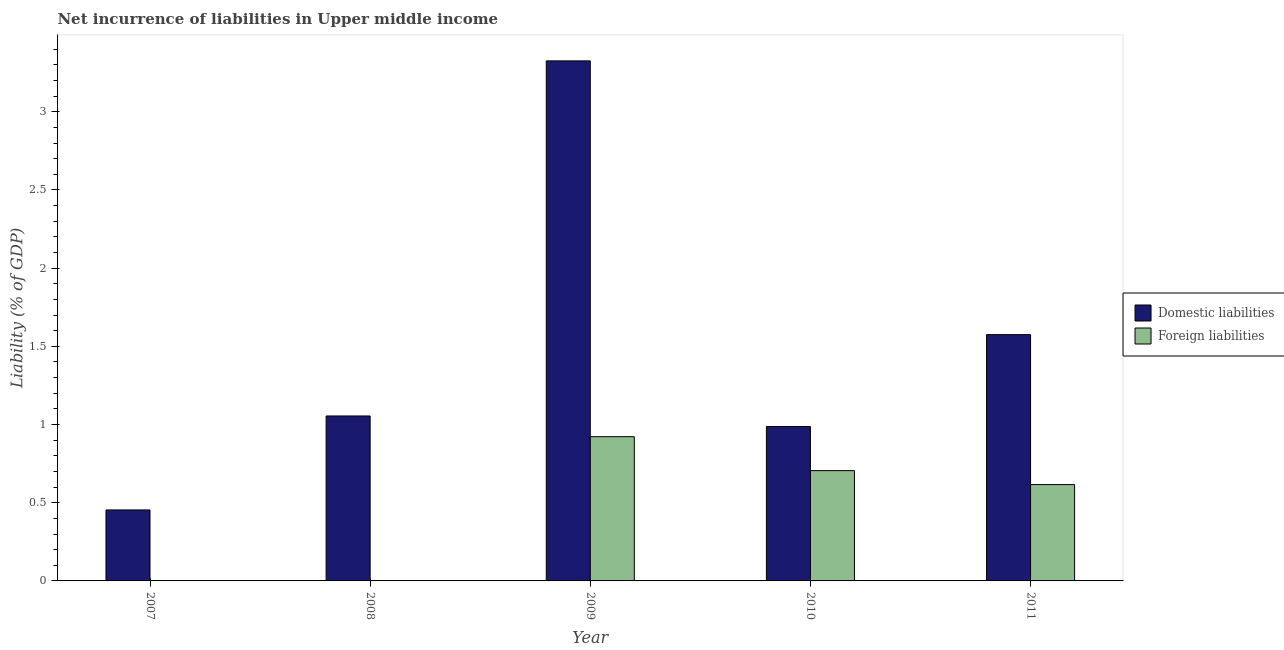Are the number of bars per tick equal to the number of legend labels?
Offer a very short reply. No. How many bars are there on the 1st tick from the left?
Your response must be concise. 1. How many bars are there on the 3rd tick from the right?
Give a very brief answer. 2. What is the incurrence of domestic liabilities in 2008?
Keep it short and to the point. 1.05. Across all years, what is the maximum incurrence of foreign liabilities?
Provide a short and direct response. 0.92. Across all years, what is the minimum incurrence of domestic liabilities?
Your answer should be compact. 0.45. In which year was the incurrence of domestic liabilities maximum?
Ensure brevity in your answer.  2009. What is the total incurrence of domestic liabilities in the graph?
Ensure brevity in your answer.  7.4. What is the difference between the incurrence of foreign liabilities in 2009 and that in 2011?
Provide a succinct answer. 0.31. What is the average incurrence of domestic liabilities per year?
Keep it short and to the point. 1.48. In the year 2011, what is the difference between the incurrence of foreign liabilities and incurrence of domestic liabilities?
Provide a succinct answer. 0. In how many years, is the incurrence of foreign liabilities greater than 2.1 %?
Keep it short and to the point. 0. What is the ratio of the incurrence of foreign liabilities in 2010 to that in 2011?
Offer a very short reply. 1.14. What is the difference between the highest and the second highest incurrence of domestic liabilities?
Ensure brevity in your answer.  1.75. What is the difference between the highest and the lowest incurrence of domestic liabilities?
Offer a terse response. 2.87. In how many years, is the incurrence of foreign liabilities greater than the average incurrence of foreign liabilities taken over all years?
Give a very brief answer. 3. Is the sum of the incurrence of foreign liabilities in 2010 and 2011 greater than the maximum incurrence of domestic liabilities across all years?
Provide a succinct answer. Yes. How many bars are there?
Make the answer very short. 8. Are all the bars in the graph horizontal?
Ensure brevity in your answer.  No. How many years are there in the graph?
Your answer should be very brief. 5. What is the difference between two consecutive major ticks on the Y-axis?
Keep it short and to the point. 0.5. Are the values on the major ticks of Y-axis written in scientific E-notation?
Your response must be concise. No. Does the graph contain grids?
Your response must be concise. No. Where does the legend appear in the graph?
Your answer should be very brief. Center right. How many legend labels are there?
Offer a very short reply. 2. How are the legend labels stacked?
Keep it short and to the point. Vertical. What is the title of the graph?
Keep it short and to the point. Net incurrence of liabilities in Upper middle income. Does "Net savings(excluding particulate emission damage)" appear as one of the legend labels in the graph?
Your response must be concise. No. What is the label or title of the Y-axis?
Your answer should be very brief. Liability (% of GDP). What is the Liability (% of GDP) of Domestic liabilities in 2007?
Make the answer very short. 0.45. What is the Liability (% of GDP) in Foreign liabilities in 2007?
Ensure brevity in your answer.  0. What is the Liability (% of GDP) in Domestic liabilities in 2008?
Keep it short and to the point. 1.05. What is the Liability (% of GDP) of Foreign liabilities in 2008?
Provide a succinct answer. 0. What is the Liability (% of GDP) of Domestic liabilities in 2009?
Make the answer very short. 3.33. What is the Liability (% of GDP) of Foreign liabilities in 2009?
Give a very brief answer. 0.92. What is the Liability (% of GDP) in Domestic liabilities in 2010?
Keep it short and to the point. 0.99. What is the Liability (% of GDP) in Foreign liabilities in 2010?
Your answer should be compact. 0.71. What is the Liability (% of GDP) of Domestic liabilities in 2011?
Keep it short and to the point. 1.57. What is the Liability (% of GDP) in Foreign liabilities in 2011?
Your response must be concise. 0.62. Across all years, what is the maximum Liability (% of GDP) of Domestic liabilities?
Ensure brevity in your answer.  3.33. Across all years, what is the maximum Liability (% of GDP) in Foreign liabilities?
Offer a very short reply. 0.92. Across all years, what is the minimum Liability (% of GDP) of Domestic liabilities?
Ensure brevity in your answer.  0.45. What is the total Liability (% of GDP) in Domestic liabilities in the graph?
Keep it short and to the point. 7.4. What is the total Liability (% of GDP) in Foreign liabilities in the graph?
Make the answer very short. 2.24. What is the difference between the Liability (% of GDP) in Domestic liabilities in 2007 and that in 2008?
Provide a short and direct response. -0.6. What is the difference between the Liability (% of GDP) in Domestic liabilities in 2007 and that in 2009?
Give a very brief answer. -2.87. What is the difference between the Liability (% of GDP) of Domestic liabilities in 2007 and that in 2010?
Offer a very short reply. -0.53. What is the difference between the Liability (% of GDP) in Domestic liabilities in 2007 and that in 2011?
Provide a succinct answer. -1.12. What is the difference between the Liability (% of GDP) of Domestic liabilities in 2008 and that in 2009?
Keep it short and to the point. -2.27. What is the difference between the Liability (% of GDP) in Domestic liabilities in 2008 and that in 2010?
Make the answer very short. 0.07. What is the difference between the Liability (% of GDP) of Domestic liabilities in 2008 and that in 2011?
Your response must be concise. -0.52. What is the difference between the Liability (% of GDP) in Domestic liabilities in 2009 and that in 2010?
Keep it short and to the point. 2.34. What is the difference between the Liability (% of GDP) of Foreign liabilities in 2009 and that in 2010?
Your answer should be compact. 0.22. What is the difference between the Liability (% of GDP) in Domestic liabilities in 2009 and that in 2011?
Offer a terse response. 1.75. What is the difference between the Liability (% of GDP) of Foreign liabilities in 2009 and that in 2011?
Provide a short and direct response. 0.31. What is the difference between the Liability (% of GDP) of Domestic liabilities in 2010 and that in 2011?
Make the answer very short. -0.59. What is the difference between the Liability (% of GDP) in Foreign liabilities in 2010 and that in 2011?
Keep it short and to the point. 0.09. What is the difference between the Liability (% of GDP) in Domestic liabilities in 2007 and the Liability (% of GDP) in Foreign liabilities in 2009?
Make the answer very short. -0.47. What is the difference between the Liability (% of GDP) of Domestic liabilities in 2007 and the Liability (% of GDP) of Foreign liabilities in 2010?
Your answer should be compact. -0.25. What is the difference between the Liability (% of GDP) in Domestic liabilities in 2007 and the Liability (% of GDP) in Foreign liabilities in 2011?
Provide a succinct answer. -0.16. What is the difference between the Liability (% of GDP) of Domestic liabilities in 2008 and the Liability (% of GDP) of Foreign liabilities in 2009?
Provide a short and direct response. 0.13. What is the difference between the Liability (% of GDP) in Domestic liabilities in 2008 and the Liability (% of GDP) in Foreign liabilities in 2010?
Your answer should be compact. 0.35. What is the difference between the Liability (% of GDP) of Domestic liabilities in 2008 and the Liability (% of GDP) of Foreign liabilities in 2011?
Your response must be concise. 0.44. What is the difference between the Liability (% of GDP) of Domestic liabilities in 2009 and the Liability (% of GDP) of Foreign liabilities in 2010?
Ensure brevity in your answer.  2.62. What is the difference between the Liability (% of GDP) in Domestic liabilities in 2009 and the Liability (% of GDP) in Foreign liabilities in 2011?
Offer a terse response. 2.71. What is the difference between the Liability (% of GDP) in Domestic liabilities in 2010 and the Liability (% of GDP) in Foreign liabilities in 2011?
Your answer should be very brief. 0.37. What is the average Liability (% of GDP) in Domestic liabilities per year?
Offer a very short reply. 1.48. What is the average Liability (% of GDP) in Foreign liabilities per year?
Your response must be concise. 0.45. In the year 2009, what is the difference between the Liability (% of GDP) of Domestic liabilities and Liability (% of GDP) of Foreign liabilities?
Provide a succinct answer. 2.4. In the year 2010, what is the difference between the Liability (% of GDP) of Domestic liabilities and Liability (% of GDP) of Foreign liabilities?
Your response must be concise. 0.28. In the year 2011, what is the difference between the Liability (% of GDP) of Domestic liabilities and Liability (% of GDP) of Foreign liabilities?
Provide a short and direct response. 0.96. What is the ratio of the Liability (% of GDP) of Domestic liabilities in 2007 to that in 2008?
Offer a very short reply. 0.43. What is the ratio of the Liability (% of GDP) of Domestic liabilities in 2007 to that in 2009?
Your answer should be compact. 0.14. What is the ratio of the Liability (% of GDP) in Domestic liabilities in 2007 to that in 2010?
Your answer should be very brief. 0.46. What is the ratio of the Liability (% of GDP) of Domestic liabilities in 2007 to that in 2011?
Give a very brief answer. 0.29. What is the ratio of the Liability (% of GDP) in Domestic liabilities in 2008 to that in 2009?
Offer a terse response. 0.32. What is the ratio of the Liability (% of GDP) in Domestic liabilities in 2008 to that in 2010?
Ensure brevity in your answer.  1.07. What is the ratio of the Liability (% of GDP) of Domestic liabilities in 2008 to that in 2011?
Your answer should be compact. 0.67. What is the ratio of the Liability (% of GDP) of Domestic liabilities in 2009 to that in 2010?
Your answer should be very brief. 3.37. What is the ratio of the Liability (% of GDP) in Foreign liabilities in 2009 to that in 2010?
Your answer should be compact. 1.31. What is the ratio of the Liability (% of GDP) of Domestic liabilities in 2009 to that in 2011?
Your answer should be very brief. 2.11. What is the ratio of the Liability (% of GDP) of Foreign liabilities in 2009 to that in 2011?
Offer a terse response. 1.5. What is the ratio of the Liability (% of GDP) of Domestic liabilities in 2010 to that in 2011?
Your answer should be very brief. 0.63. What is the ratio of the Liability (% of GDP) of Foreign liabilities in 2010 to that in 2011?
Your response must be concise. 1.14. What is the difference between the highest and the second highest Liability (% of GDP) in Domestic liabilities?
Keep it short and to the point. 1.75. What is the difference between the highest and the second highest Liability (% of GDP) in Foreign liabilities?
Give a very brief answer. 0.22. What is the difference between the highest and the lowest Liability (% of GDP) of Domestic liabilities?
Keep it short and to the point. 2.87. What is the difference between the highest and the lowest Liability (% of GDP) in Foreign liabilities?
Provide a short and direct response. 0.92. 